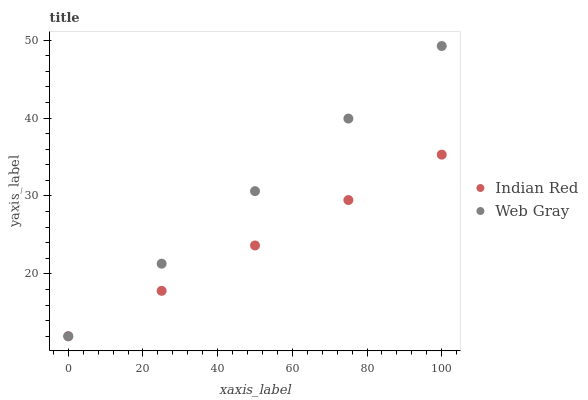Does Indian Red have the minimum area under the curve?
Answer yes or no. Yes. Does Web Gray have the maximum area under the curve?
Answer yes or no. Yes. Does Indian Red have the maximum area under the curve?
Answer yes or no. No. Is Web Gray the smoothest?
Answer yes or no. Yes. Is Indian Red the roughest?
Answer yes or no. Yes. Does Web Gray have the lowest value?
Answer yes or no. Yes. Does Web Gray have the highest value?
Answer yes or no. Yes. Does Indian Red have the highest value?
Answer yes or no. No. Does Web Gray intersect Indian Red?
Answer yes or no. Yes. Is Web Gray less than Indian Red?
Answer yes or no. No. Is Web Gray greater than Indian Red?
Answer yes or no. No. 